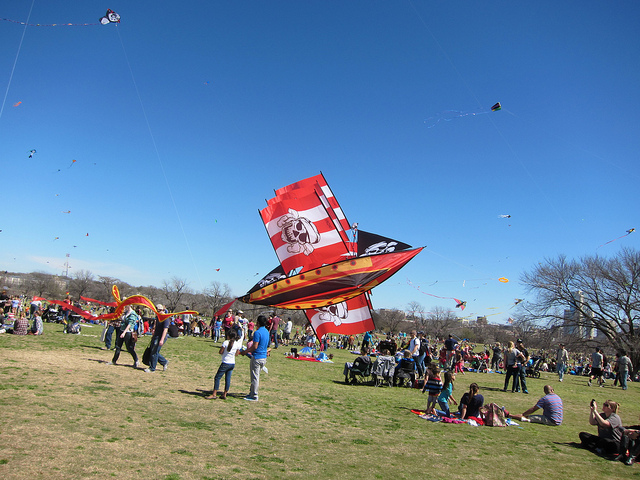<image>What type day are the people experiencing? I'm not sure what type of day the people are experiencing. It could be sunny, clear, or good. What type day are the people experiencing? I am not sure what type of day the people are experiencing. It can be a good or sunny day. 